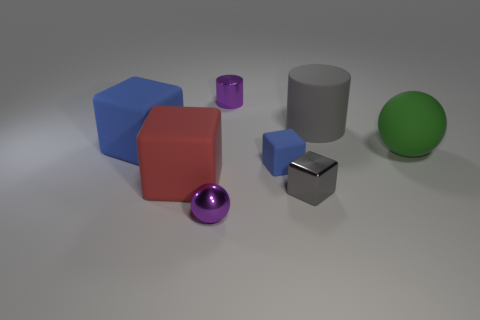Can you describe the positioning of the objects? Is there a pattern? The objects are arranged in a seemingly random manner across the surface, with no clear pattern to their placement. They are spaced apart from each other, allowing each object to be seen individually without any overlap. 